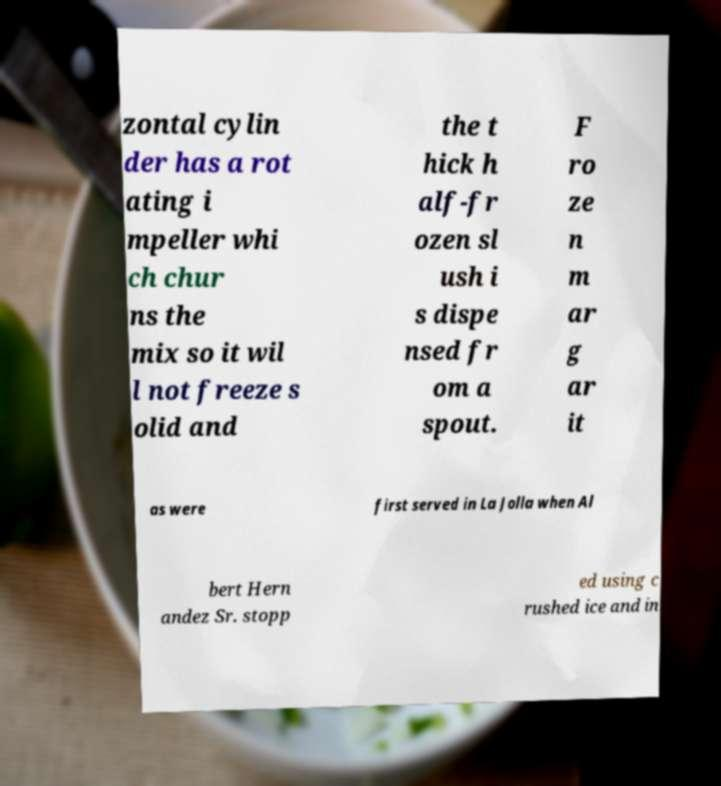There's text embedded in this image that I need extracted. Can you transcribe it verbatim? zontal cylin der has a rot ating i mpeller whi ch chur ns the mix so it wil l not freeze s olid and the t hick h alf-fr ozen sl ush i s dispe nsed fr om a spout. F ro ze n m ar g ar it as were first served in La Jolla when Al bert Hern andez Sr. stopp ed using c rushed ice and in 